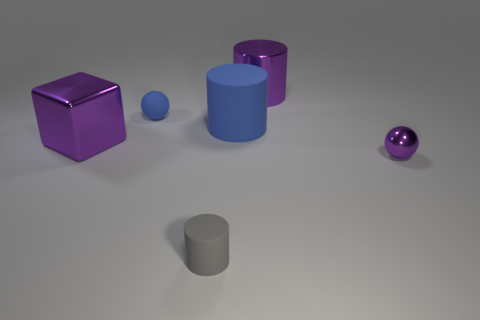Can you describe the lighting in the scene? The lighting in the scene is soft and diffuse, creating gentle shadows and subtle reflections on the objects. The light source appears to be coming from above, as indicated by the direction of the shadows cast on the ground. Does the lighting affect the color perception of the objects? Yes, the lighting can influence how we perceive the color of the objects. The soft lighting may slightly desaturate the colors, making them appear less vibrant than they would under direct or brighter lighting. 